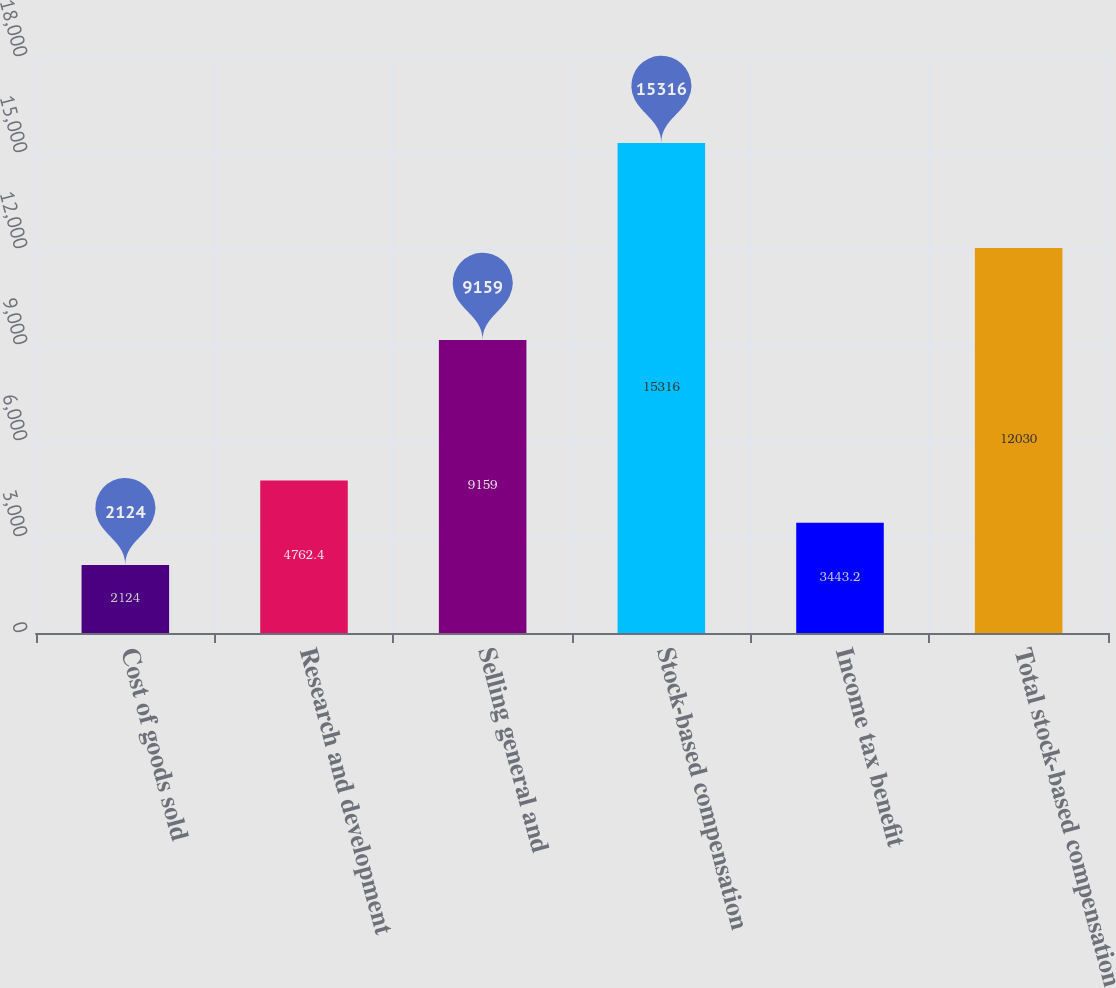Convert chart. <chart><loc_0><loc_0><loc_500><loc_500><bar_chart><fcel>Cost of goods sold<fcel>Research and development<fcel>Selling general and<fcel>Stock-based compensation<fcel>Income tax benefit<fcel>Total stock-based compensation<nl><fcel>2124<fcel>4762.4<fcel>9159<fcel>15316<fcel>3443.2<fcel>12030<nl></chart> 